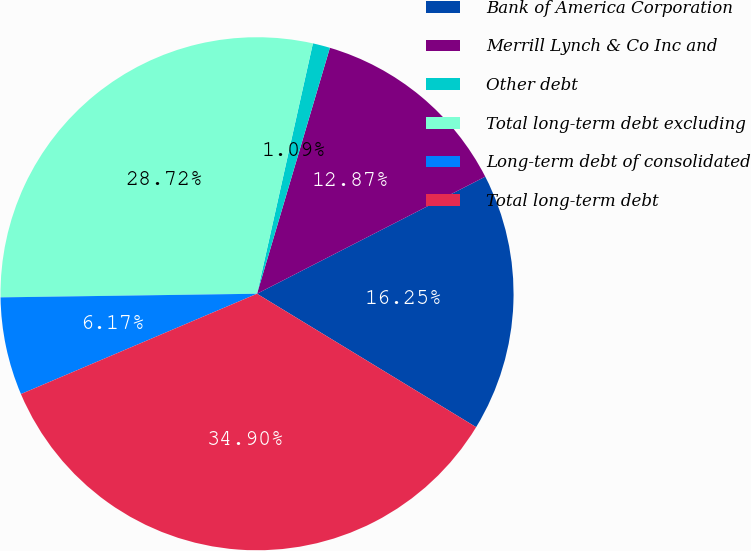Convert chart to OTSL. <chart><loc_0><loc_0><loc_500><loc_500><pie_chart><fcel>Bank of America Corporation<fcel>Merrill Lynch & Co Inc and<fcel>Other debt<fcel>Total long-term debt excluding<fcel>Long-term debt of consolidated<fcel>Total long-term debt<nl><fcel>16.25%<fcel>12.87%<fcel>1.09%<fcel>28.72%<fcel>6.17%<fcel>34.9%<nl></chart> 